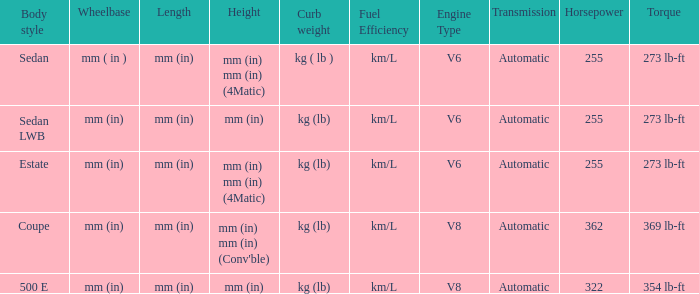What's the length of the model with Sedan body style? Mm (in). 